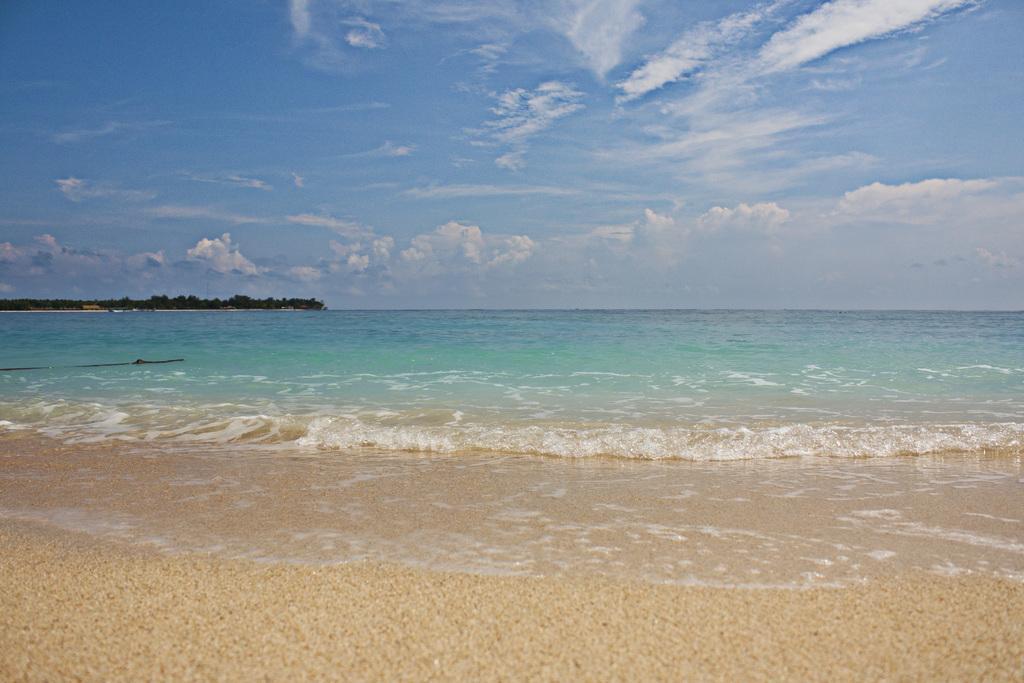Can you describe this image briefly? This is the picture of sea. Even we can see some trees here. And on the background there is a sky with heavy clouds. 